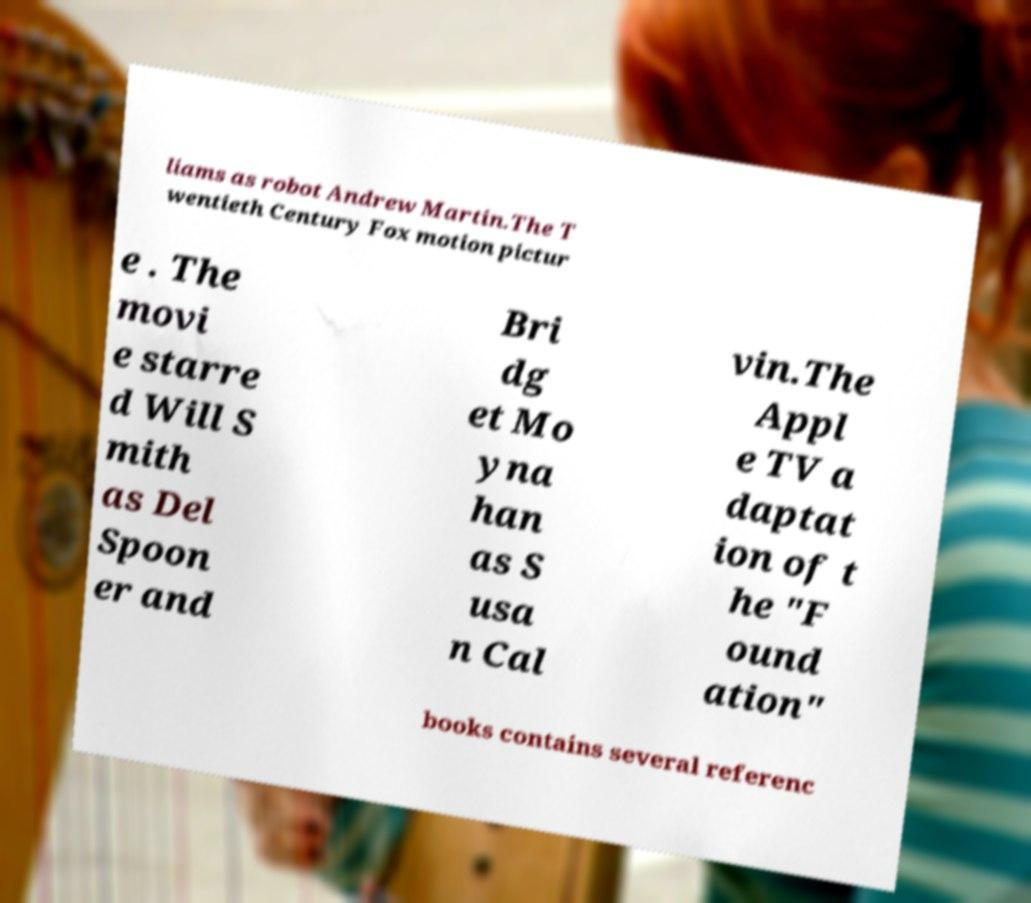Can you accurately transcribe the text from the provided image for me? liams as robot Andrew Martin.The T wentieth Century Fox motion pictur e . The movi e starre d Will S mith as Del Spoon er and Bri dg et Mo yna han as S usa n Cal vin.The Appl e TV a daptat ion of t he "F ound ation" books contains several referenc 